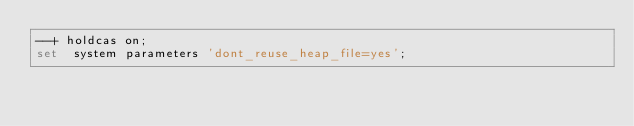<code> <loc_0><loc_0><loc_500><loc_500><_SQL_>--+ holdcas on;
set  system parameters 'dont_reuse_heap_file=yes';</code> 